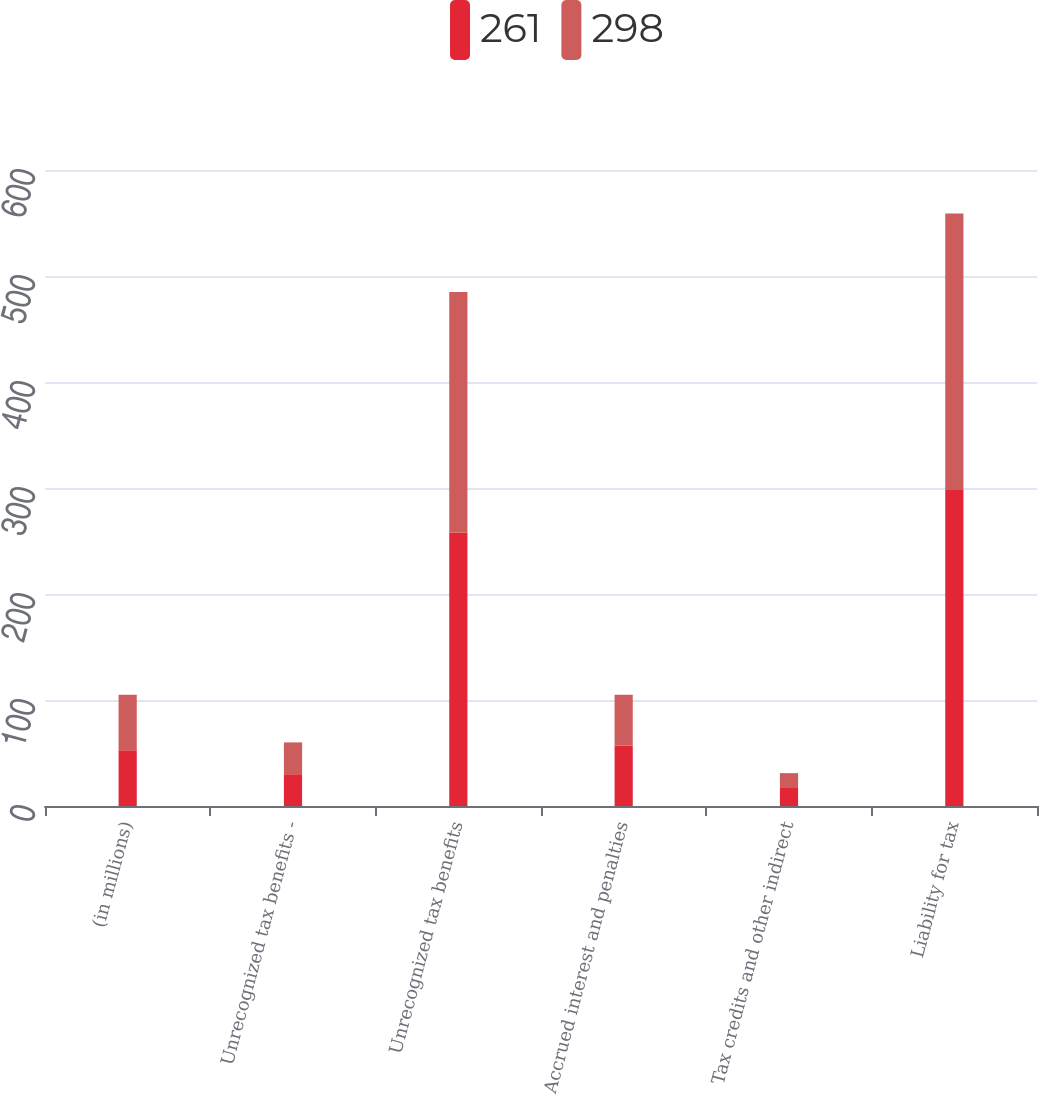Convert chart to OTSL. <chart><loc_0><loc_0><loc_500><loc_500><stacked_bar_chart><ecel><fcel>(in millions)<fcel>Unrecognized tax benefits -<fcel>Unrecognized tax benefits<fcel>Accrued interest and penalties<fcel>Tax credits and other indirect<fcel>Liability for tax<nl><fcel>261<fcel>52.5<fcel>30<fcel>258<fcel>57<fcel>17<fcel>298<nl><fcel>298<fcel>52.5<fcel>30<fcel>227<fcel>48<fcel>14<fcel>261<nl></chart> 